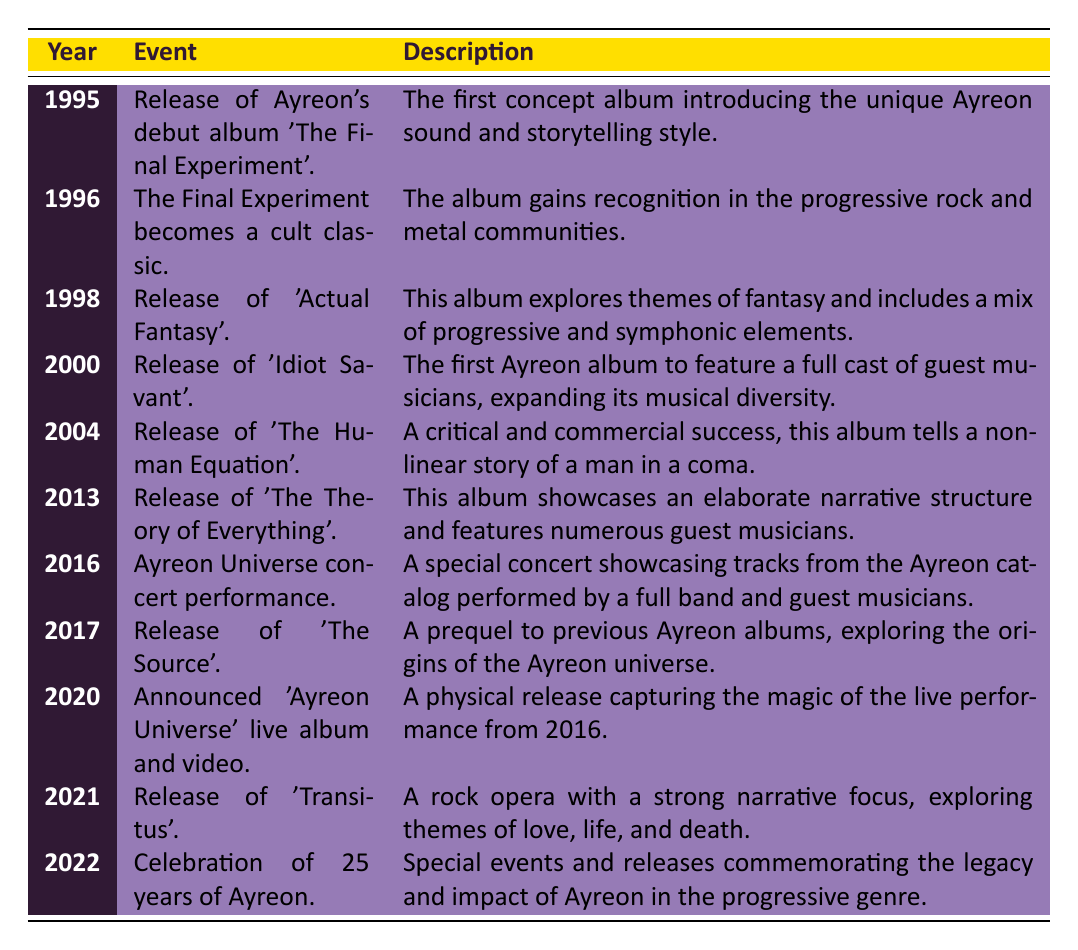What year did Ayreon release their debut album? According to the table, Ayreon's debut album 'The Final Experiment' was released in 1995. The year is mentioned in the first row under the "Year" column.
Answer: 1995 Which album became a cult classic in 1996? The event in the table for the year 1996 states that 'The Final Experiment' became a cult classic, as indicated under the "Event" column.
Answer: The Final Experiment How many years separate the release of 'Actual Fantasy' and 'The Source'? 'Actual Fantasy' was released in 1998 and 'The Source' in 2017. The difference between the two years is 2017 - 1998 = 19 years.
Answer: 19 years Is 'Transitus' the first album released after the 25th anniversary of Ayreon? The table shows 'Transitus' was released in 2021 and the 25th-anniversary celebration occurred in 2022, meaning 'Transitus' was released before the anniversary, not after.
Answer: No What is the total number of albums mentioned between 1995 and 2021? From the table, we list all albums released during that period: 'The Final Experiment', 'Actual Fantasy', 'Idiot Savant', 'The Human Equation', 'The Theory of Everything', 'The Source', and 'Transitus'. This totals to 7 albums.
Answer: 7 albums Which album was released in 2004, and what was its significance? The table states that in 2004, 'The Human Equation' was released, which is described as a critical and commercial success telling a non-linear story of a man in a coma.
Answer: The Human Equation; critical and commercial success Was there a live performance related to Ayreon in 2016? Yes, the table indicates that in 2016 there was an Ayreon Universe concert performance showcasing tracks from the Ayreon catalog, confirming the presence of a live event that year.
Answer: Yes What albums feature an elaborate narrative structure? The table mentions 'The Theory of Everything' released in 2013, which showcases an elaborate narrative structure. Additionally, 'Transitus' released in 2021 also explores a strong narrative focus, making a total of two albums.
Answer: 2 albums (The Theory of Everything and Transitus) Which album marked the anniversary celebrations in 2022? The event listed under 2022 states a celebration of 25 years of Ayreon occurred, involving special events and releases, although it does not denote a specific album title.
Answer: Celebration of 25 years of Ayreon 